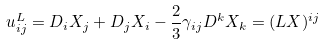<formula> <loc_0><loc_0><loc_500><loc_500>u _ { i j } ^ { L } = D _ { i } X _ { j } + D _ { j } X _ { i } - \frac { 2 } { 3 } \gamma _ { i j } D ^ { k } X _ { k } = ( L X ) ^ { i j }</formula> 